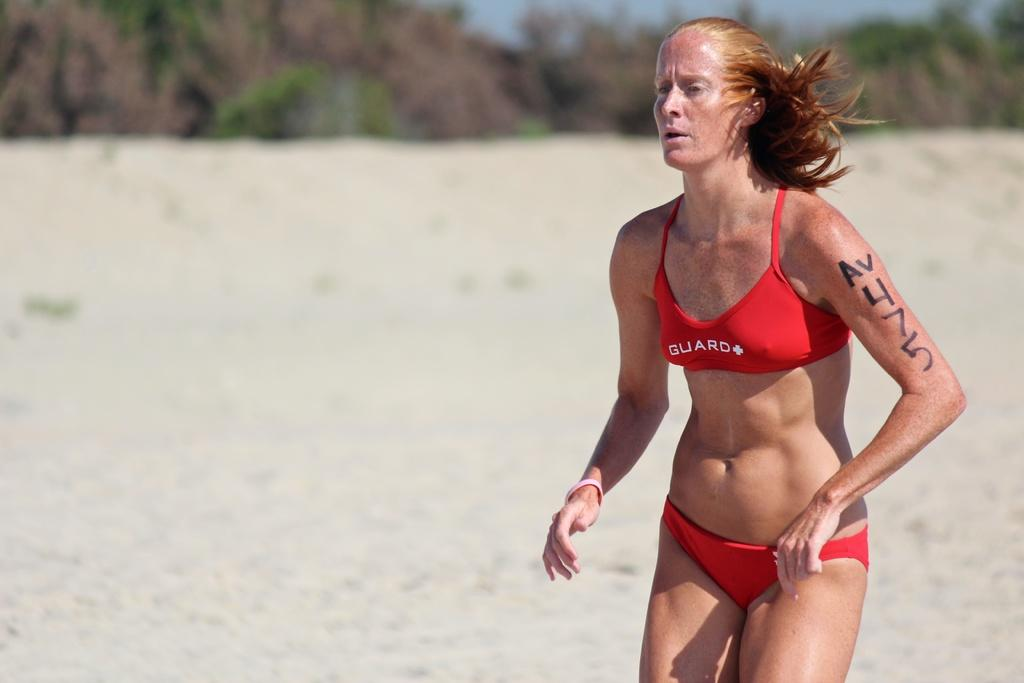<image>
Summarize the visual content of the image. A serious looking woman wears an orange bikini with GUARD written on the top. 